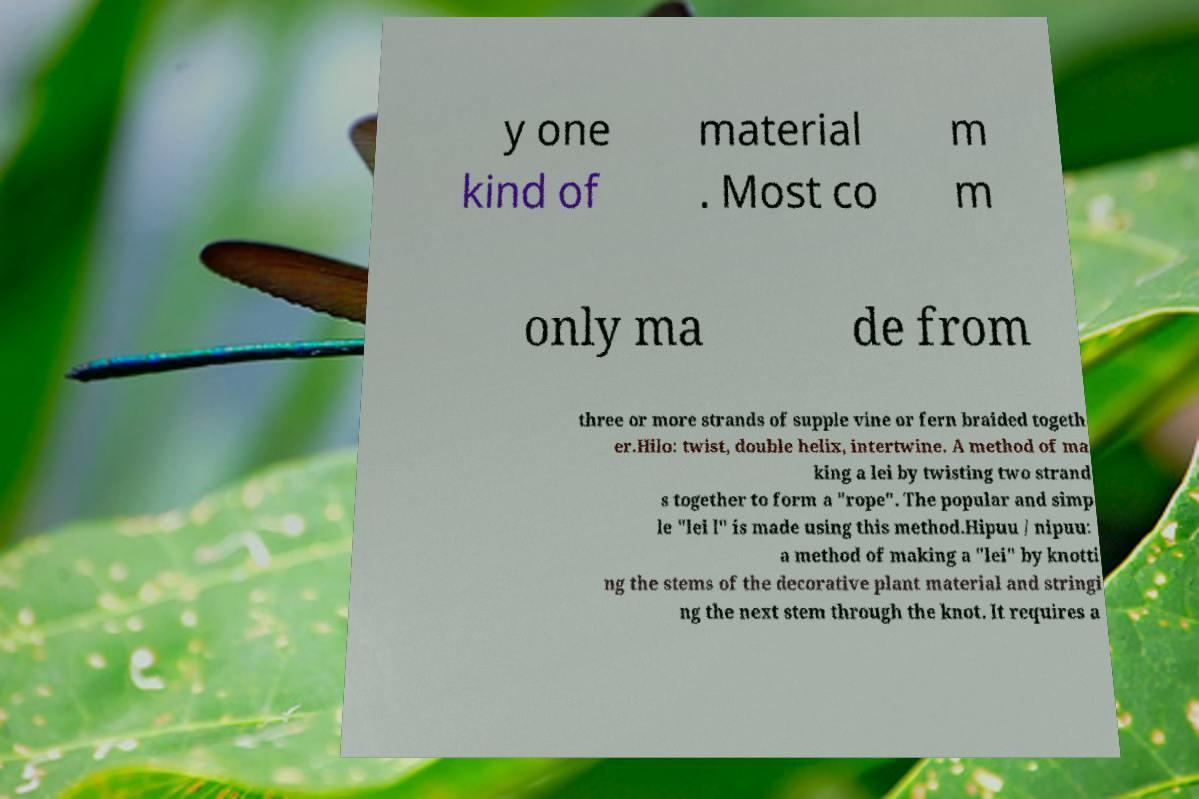Could you assist in decoding the text presented in this image and type it out clearly? y one kind of material . Most co m m only ma de from three or more strands of supple vine or fern braided togeth er.Hilo: twist, double helix, intertwine. A method of ma king a lei by twisting two strand s together to form a "rope". The popular and simp le "lei l" is made using this method.Hipuu / nipuu: a method of making a "lei" by knotti ng the stems of the decorative plant material and stringi ng the next stem through the knot. It requires a 